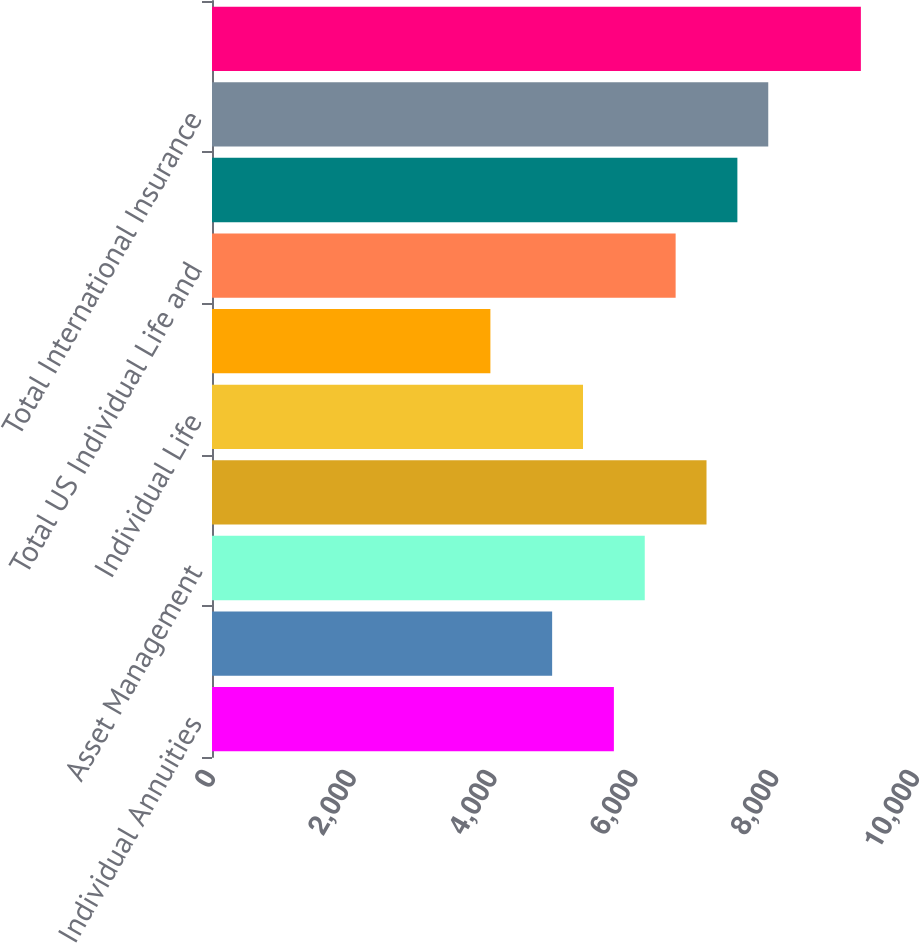Convert chart. <chart><loc_0><loc_0><loc_500><loc_500><bar_chart><fcel>Individual Annuities<fcel>Retirement<fcel>Asset Management<fcel>Total US Retirement Solutions<fcel>Individual Life<fcel>Group Insurance<fcel>Total US Individual Life and<fcel>International Insurance<fcel>Total International Insurance<fcel>Financial Services Businesses<nl><fcel>5708.62<fcel>4831.52<fcel>6147.17<fcel>7024.27<fcel>5270.07<fcel>3954.42<fcel>6585.72<fcel>7462.82<fcel>7901.37<fcel>9217.02<nl></chart> 